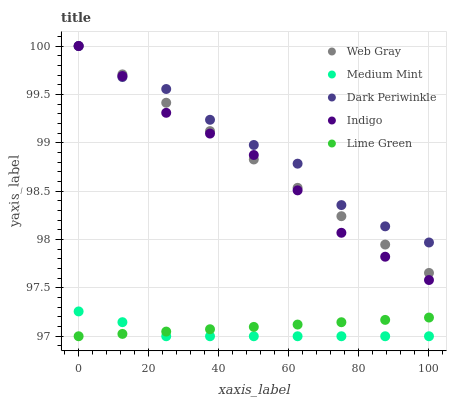Does Medium Mint have the minimum area under the curve?
Answer yes or no. Yes. Does Dark Periwinkle have the maximum area under the curve?
Answer yes or no. Yes. Does Lime Green have the minimum area under the curve?
Answer yes or no. No. Does Lime Green have the maximum area under the curve?
Answer yes or no. No. Is Lime Green the smoothest?
Answer yes or no. Yes. Is Dark Periwinkle the roughest?
Answer yes or no. Yes. Is Web Gray the smoothest?
Answer yes or no. No. Is Web Gray the roughest?
Answer yes or no. No. Does Medium Mint have the lowest value?
Answer yes or no. Yes. Does Web Gray have the lowest value?
Answer yes or no. No. Does Dark Periwinkle have the highest value?
Answer yes or no. Yes. Does Lime Green have the highest value?
Answer yes or no. No. Is Medium Mint less than Web Gray?
Answer yes or no. Yes. Is Web Gray greater than Lime Green?
Answer yes or no. Yes. Does Dark Periwinkle intersect Indigo?
Answer yes or no. Yes. Is Dark Periwinkle less than Indigo?
Answer yes or no. No. Is Dark Periwinkle greater than Indigo?
Answer yes or no. No. Does Medium Mint intersect Web Gray?
Answer yes or no. No. 